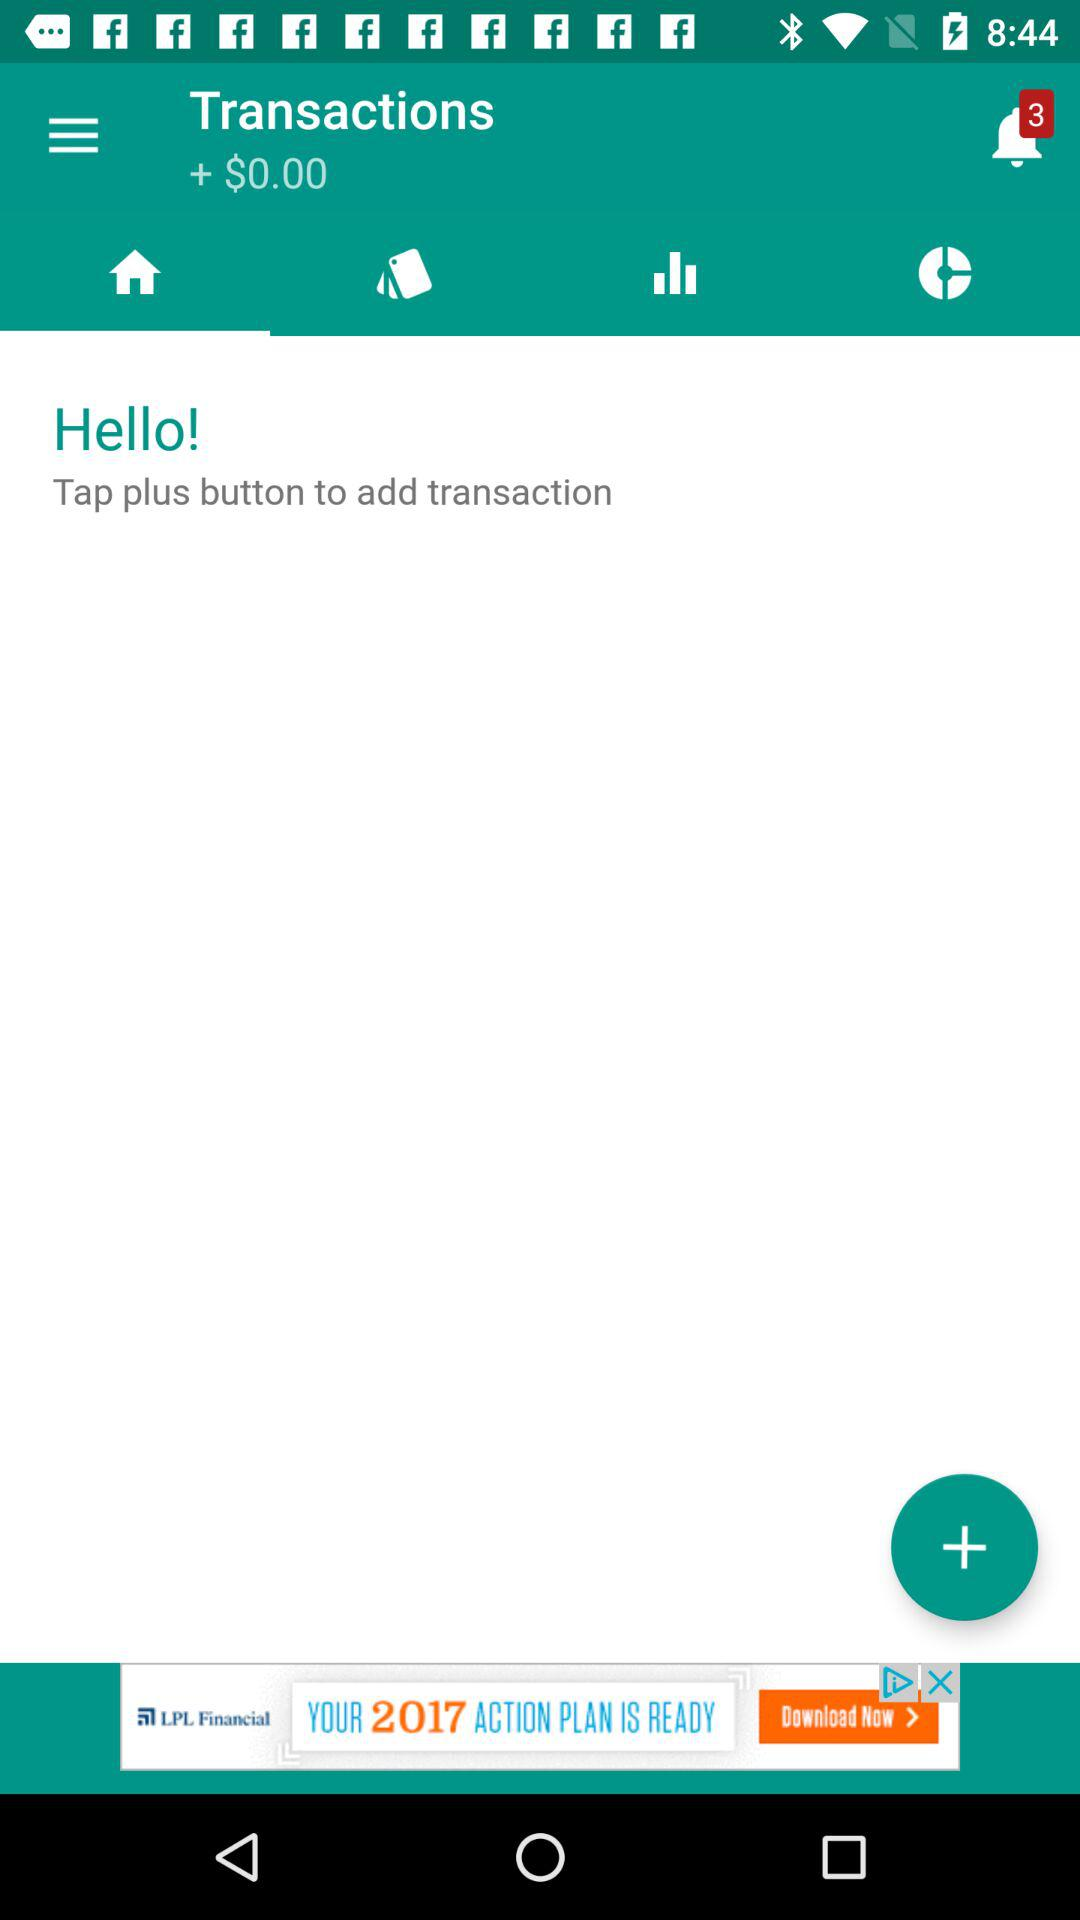How many unread notifications are there? There are 3 unread notifications. 